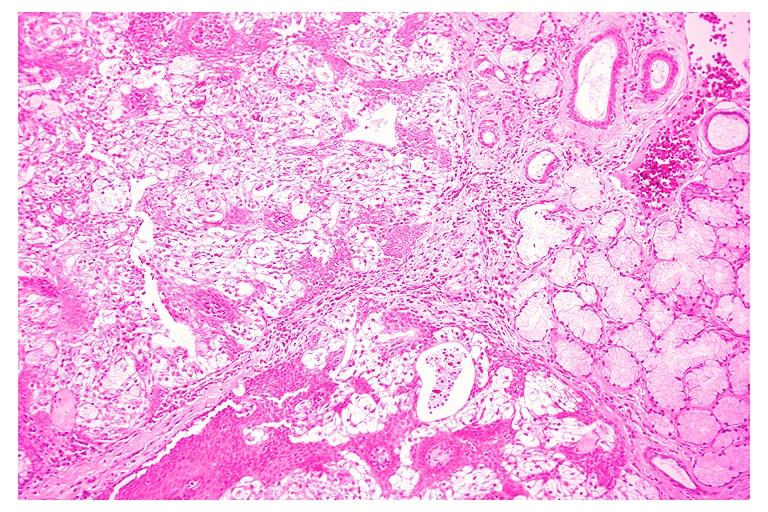s lip present?
Answer the question using a single word or phrase. No 